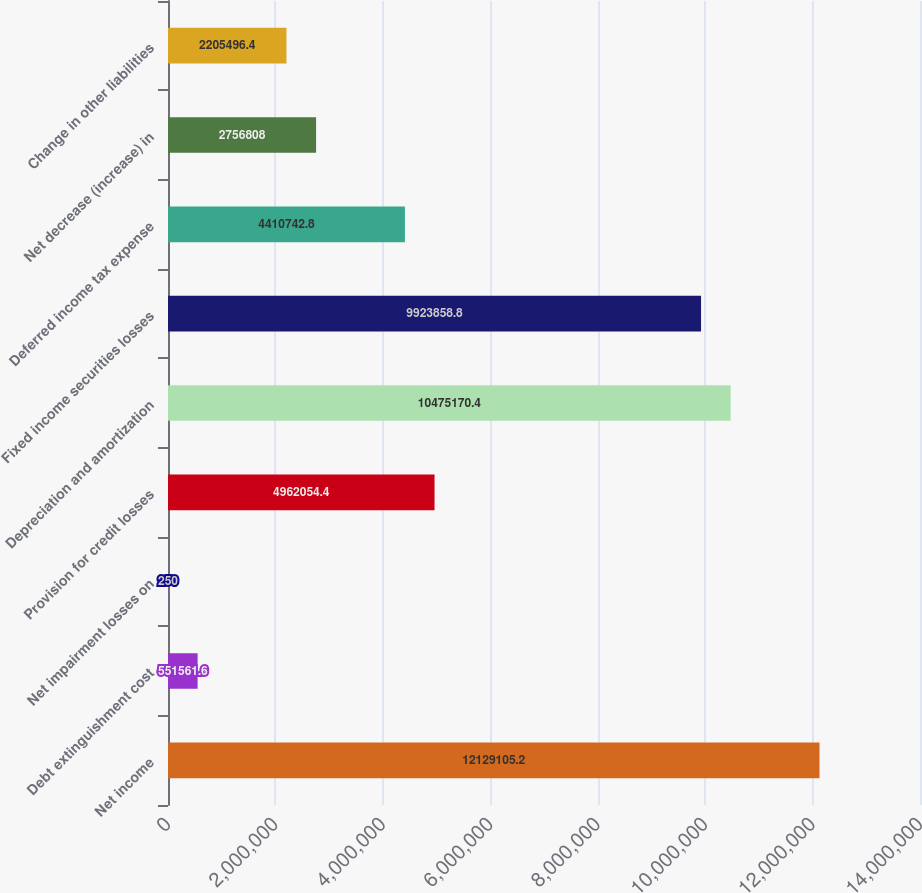<chart> <loc_0><loc_0><loc_500><loc_500><bar_chart><fcel>Net income<fcel>Debt extinguishment cost<fcel>Net impairment losses on<fcel>Provision for credit losses<fcel>Depreciation and amortization<fcel>Fixed income securities losses<fcel>Deferred income tax expense<fcel>Net decrease (increase) in<fcel>Change in other liabilities<nl><fcel>1.21291e+07<fcel>551562<fcel>250<fcel>4.96205e+06<fcel>1.04752e+07<fcel>9.92386e+06<fcel>4.41074e+06<fcel>2.75681e+06<fcel>2.2055e+06<nl></chart> 